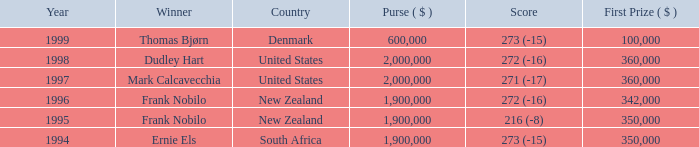What was the overall prize money in the years following 1996 when frank nobilo achieved a score of 272 (-16) and won? None. 